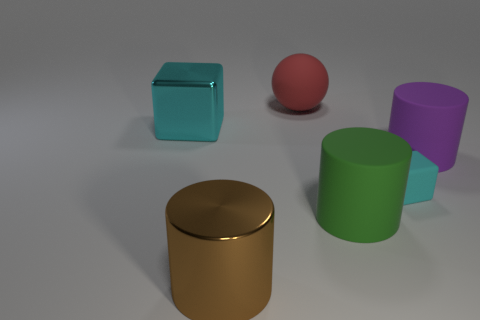Add 3 rubber cylinders. How many objects exist? 9 Subtract all blocks. How many objects are left? 4 Add 4 large brown shiny things. How many large brown shiny things are left? 5 Add 5 big gray things. How many big gray things exist? 5 Subtract 0 green blocks. How many objects are left? 6 Subtract all cyan matte things. Subtract all purple rubber cylinders. How many objects are left? 4 